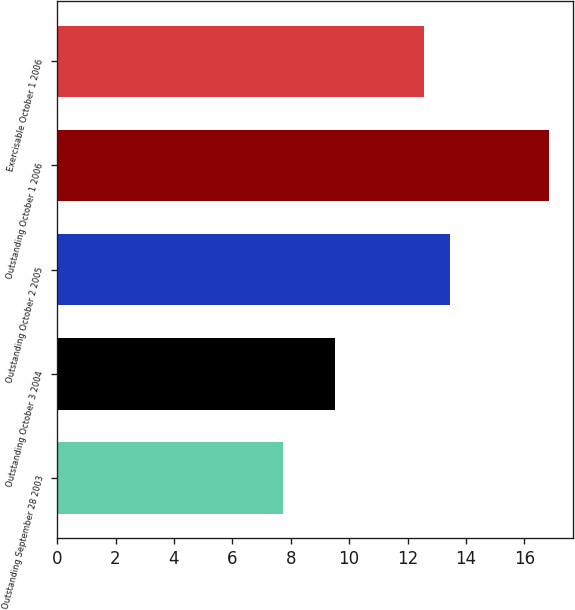Convert chart to OTSL. <chart><loc_0><loc_0><loc_500><loc_500><bar_chart><fcel>Outstanding September 28 2003<fcel>Outstanding October 3 2004<fcel>Outstanding October 2 2005<fcel>Outstanding October 1 2006<fcel>Exercisable October 1 2006<nl><fcel>7.74<fcel>9.52<fcel>13.47<fcel>16.83<fcel>12.56<nl></chart> 